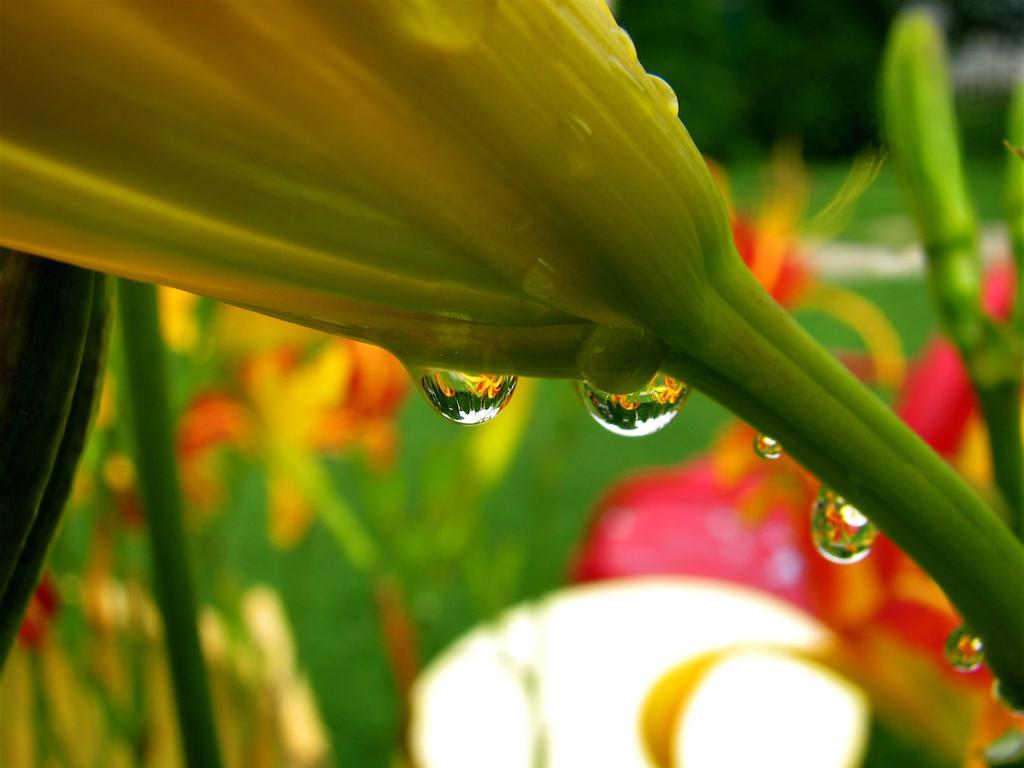What is the main subject of the image? There is a flower in the image. Can you describe the flower in more detail? There are water drops on the flower. How would you describe the background of the image? The background of the image is blurred. What type of road can be seen in the background of the image? There is no road visible in the image; the background is blurred. What role does the flower play in leading the water drops? The flower does not lead the water drops; it is simply the subject of the image with water drops on it. 